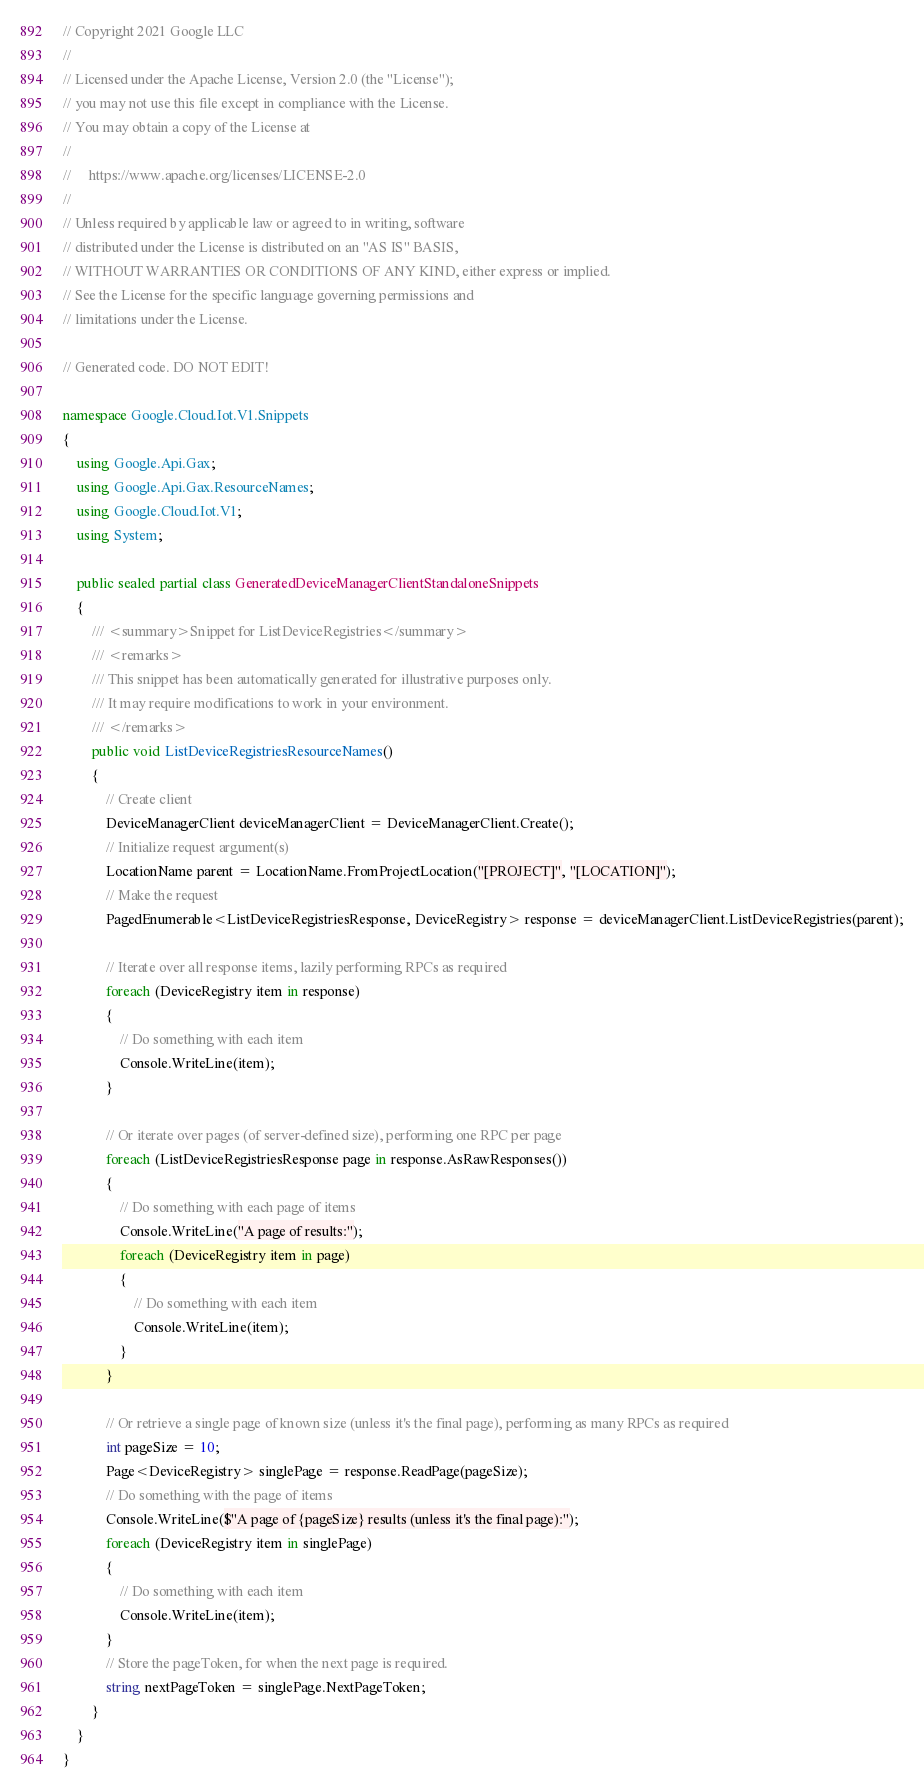Convert code to text. <code><loc_0><loc_0><loc_500><loc_500><_C#_>// Copyright 2021 Google LLC
//
// Licensed under the Apache License, Version 2.0 (the "License");
// you may not use this file except in compliance with the License.
// You may obtain a copy of the License at
//
//     https://www.apache.org/licenses/LICENSE-2.0
//
// Unless required by applicable law or agreed to in writing, software
// distributed under the License is distributed on an "AS IS" BASIS,
// WITHOUT WARRANTIES OR CONDITIONS OF ANY KIND, either express or implied.
// See the License for the specific language governing permissions and
// limitations under the License.

// Generated code. DO NOT EDIT!

namespace Google.Cloud.Iot.V1.Snippets
{
    using Google.Api.Gax;
    using Google.Api.Gax.ResourceNames;
    using Google.Cloud.Iot.V1;
    using System;

    public sealed partial class GeneratedDeviceManagerClientStandaloneSnippets
    {
        /// <summary>Snippet for ListDeviceRegistries</summary>
        /// <remarks>
        /// This snippet has been automatically generated for illustrative purposes only.
        /// It may require modifications to work in your environment.
        /// </remarks>
        public void ListDeviceRegistriesResourceNames()
        {
            // Create client
            DeviceManagerClient deviceManagerClient = DeviceManagerClient.Create();
            // Initialize request argument(s)
            LocationName parent = LocationName.FromProjectLocation("[PROJECT]", "[LOCATION]");
            // Make the request
            PagedEnumerable<ListDeviceRegistriesResponse, DeviceRegistry> response = deviceManagerClient.ListDeviceRegistries(parent);

            // Iterate over all response items, lazily performing RPCs as required
            foreach (DeviceRegistry item in response)
            {
                // Do something with each item
                Console.WriteLine(item);
            }

            // Or iterate over pages (of server-defined size), performing one RPC per page
            foreach (ListDeviceRegistriesResponse page in response.AsRawResponses())
            {
                // Do something with each page of items
                Console.WriteLine("A page of results:");
                foreach (DeviceRegistry item in page)
                {
                    // Do something with each item
                    Console.WriteLine(item);
                }
            }

            // Or retrieve a single page of known size (unless it's the final page), performing as many RPCs as required
            int pageSize = 10;
            Page<DeviceRegistry> singlePage = response.ReadPage(pageSize);
            // Do something with the page of items
            Console.WriteLine($"A page of {pageSize} results (unless it's the final page):");
            foreach (DeviceRegistry item in singlePage)
            {
                // Do something with each item
                Console.WriteLine(item);
            }
            // Store the pageToken, for when the next page is required.
            string nextPageToken = singlePage.NextPageToken;
        }
    }
}
</code> 